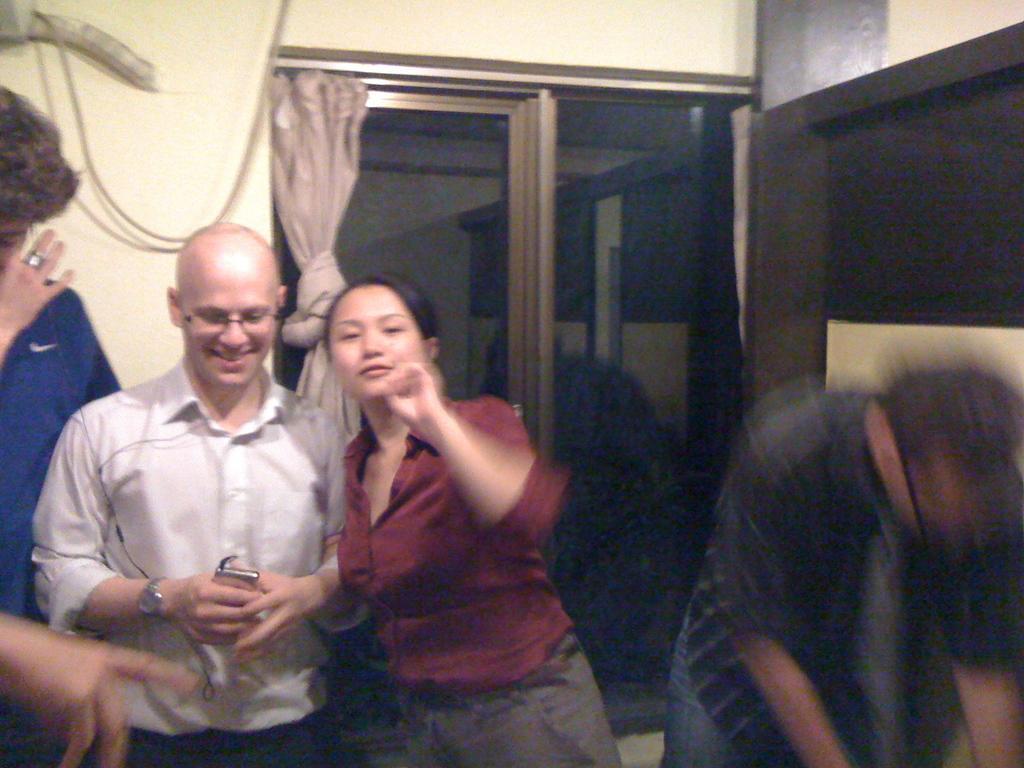Can you describe this image briefly? In this image there is a woman in the middle who is holding the hand of a man who is beside her. In the background there is a window. On the left side there is a man standing on the floor who is wearing the blue colour shirt. In the background there is a curtain and a wire. 